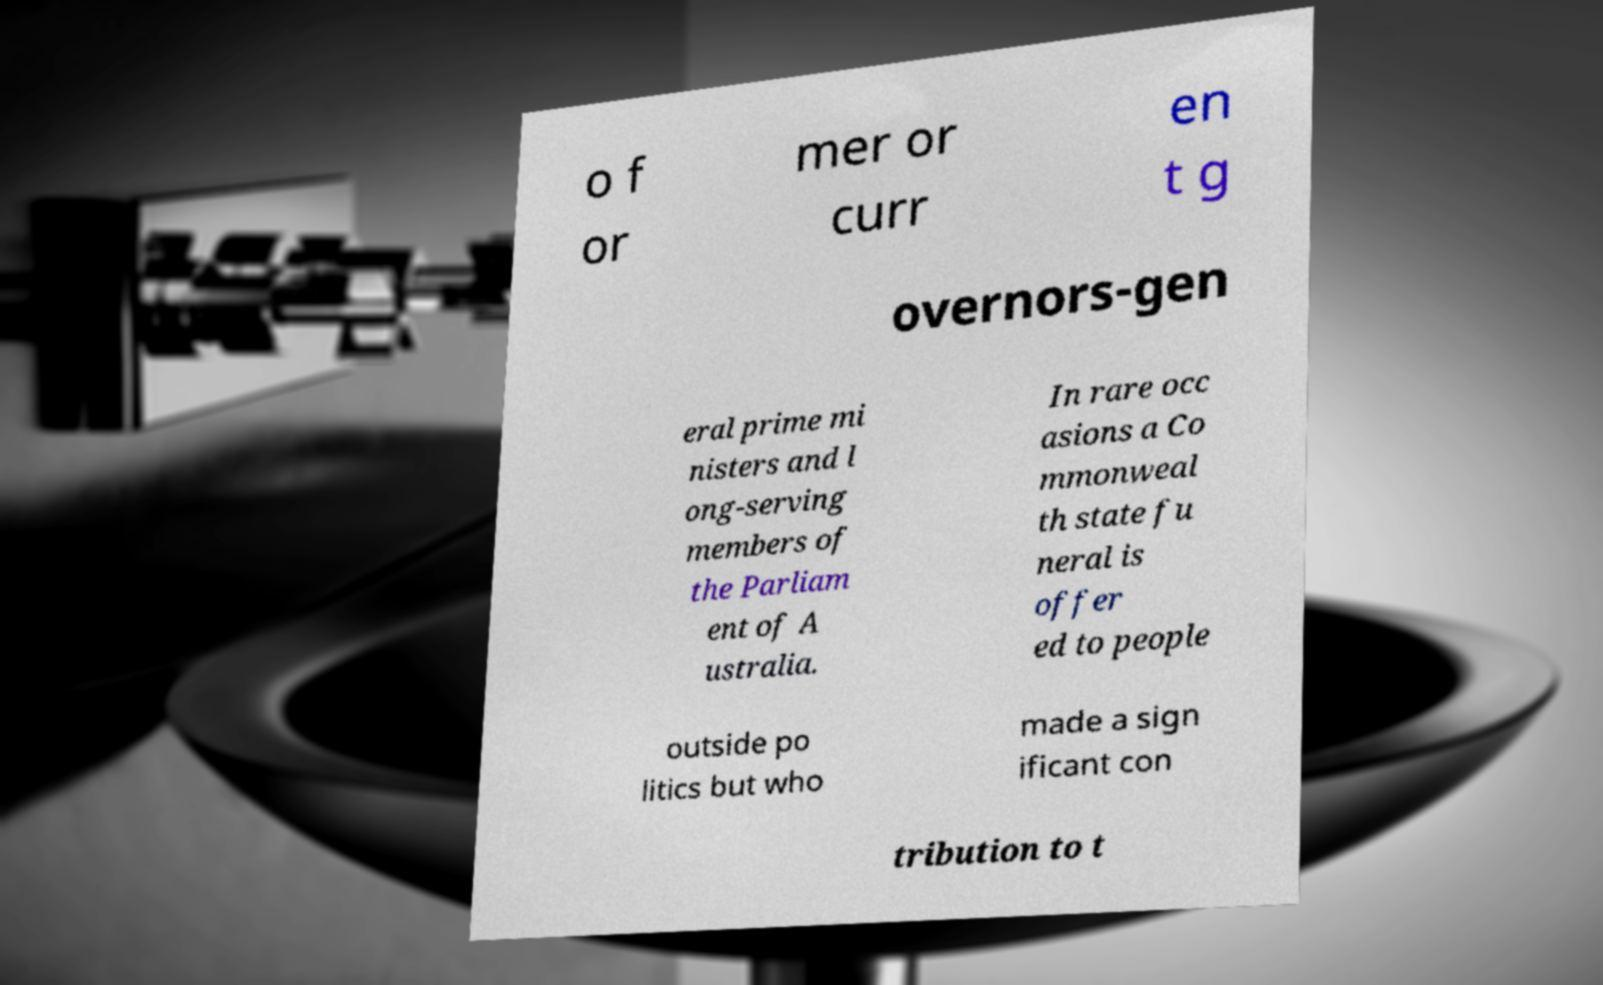Please read and relay the text visible in this image. What does it say? o f or mer or curr en t g overnors-gen eral prime mi nisters and l ong-serving members of the Parliam ent of A ustralia. In rare occ asions a Co mmonweal th state fu neral is offer ed to people outside po litics but who made a sign ificant con tribution to t 